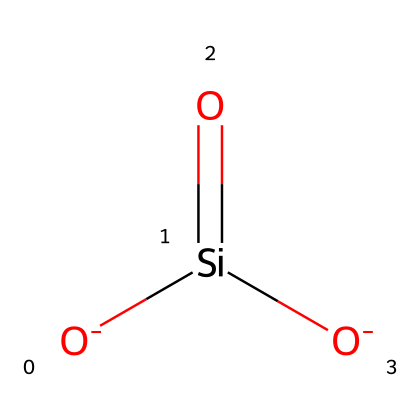What atoms are present in this molecule? The SMILES representation shows the presence of silicon (Si) and oxygen (O) atoms. Each of the [O-] indicates an oxygen atom while Si in the middle indicates the presence of a silicon atom.
Answer: silicon, oxygen How many oxygen atoms are in this molecule? Upon examining the SMILES, there are three oxygen atoms: two are indicated as [O-] and one is part of the silicon dioxide (Si=O).
Answer: three What is the oxidation state of silicon in this molecule? In the structure, silicon is bonded to two negatively charged oxygen atoms and one double-bonded oxygen, suggesting that it fulfills its four valences while maintaining a neutral overall charge. Thus, the oxidation state of silicon here is +4.
Answer: +4 What type of bonding is present between silicon and oxygen? The bond between silicon (Si) and oxygen (O) in the given structure includes both ionic interactions (due to the negative charges on oxygen) and covalent bonding (with the Si=O).
Answer: ionic, covalent What characteristic feature of this coating contributes to its durability? The presence of silicon-oxygen bonds (especially in a tetrahedral arrangement Common in silicates) provides structural integrity, creating a robust network that enhances the durability of the ceramic coating.
Answer: silicon-oxygen bonds What type of chemical is this molecule likely to represent? Given the structure with silicon dioxide characteristics, this molecule resembles a silicate compound common in ceramic coatings known for their protective properties.
Answer: silicate 